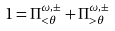Convert formula to latex. <formula><loc_0><loc_0><loc_500><loc_500>1 = \Pi ^ { \omega , \pm } _ { < \theta } + \Pi ^ { \omega , \pm } _ { > \theta }</formula> 